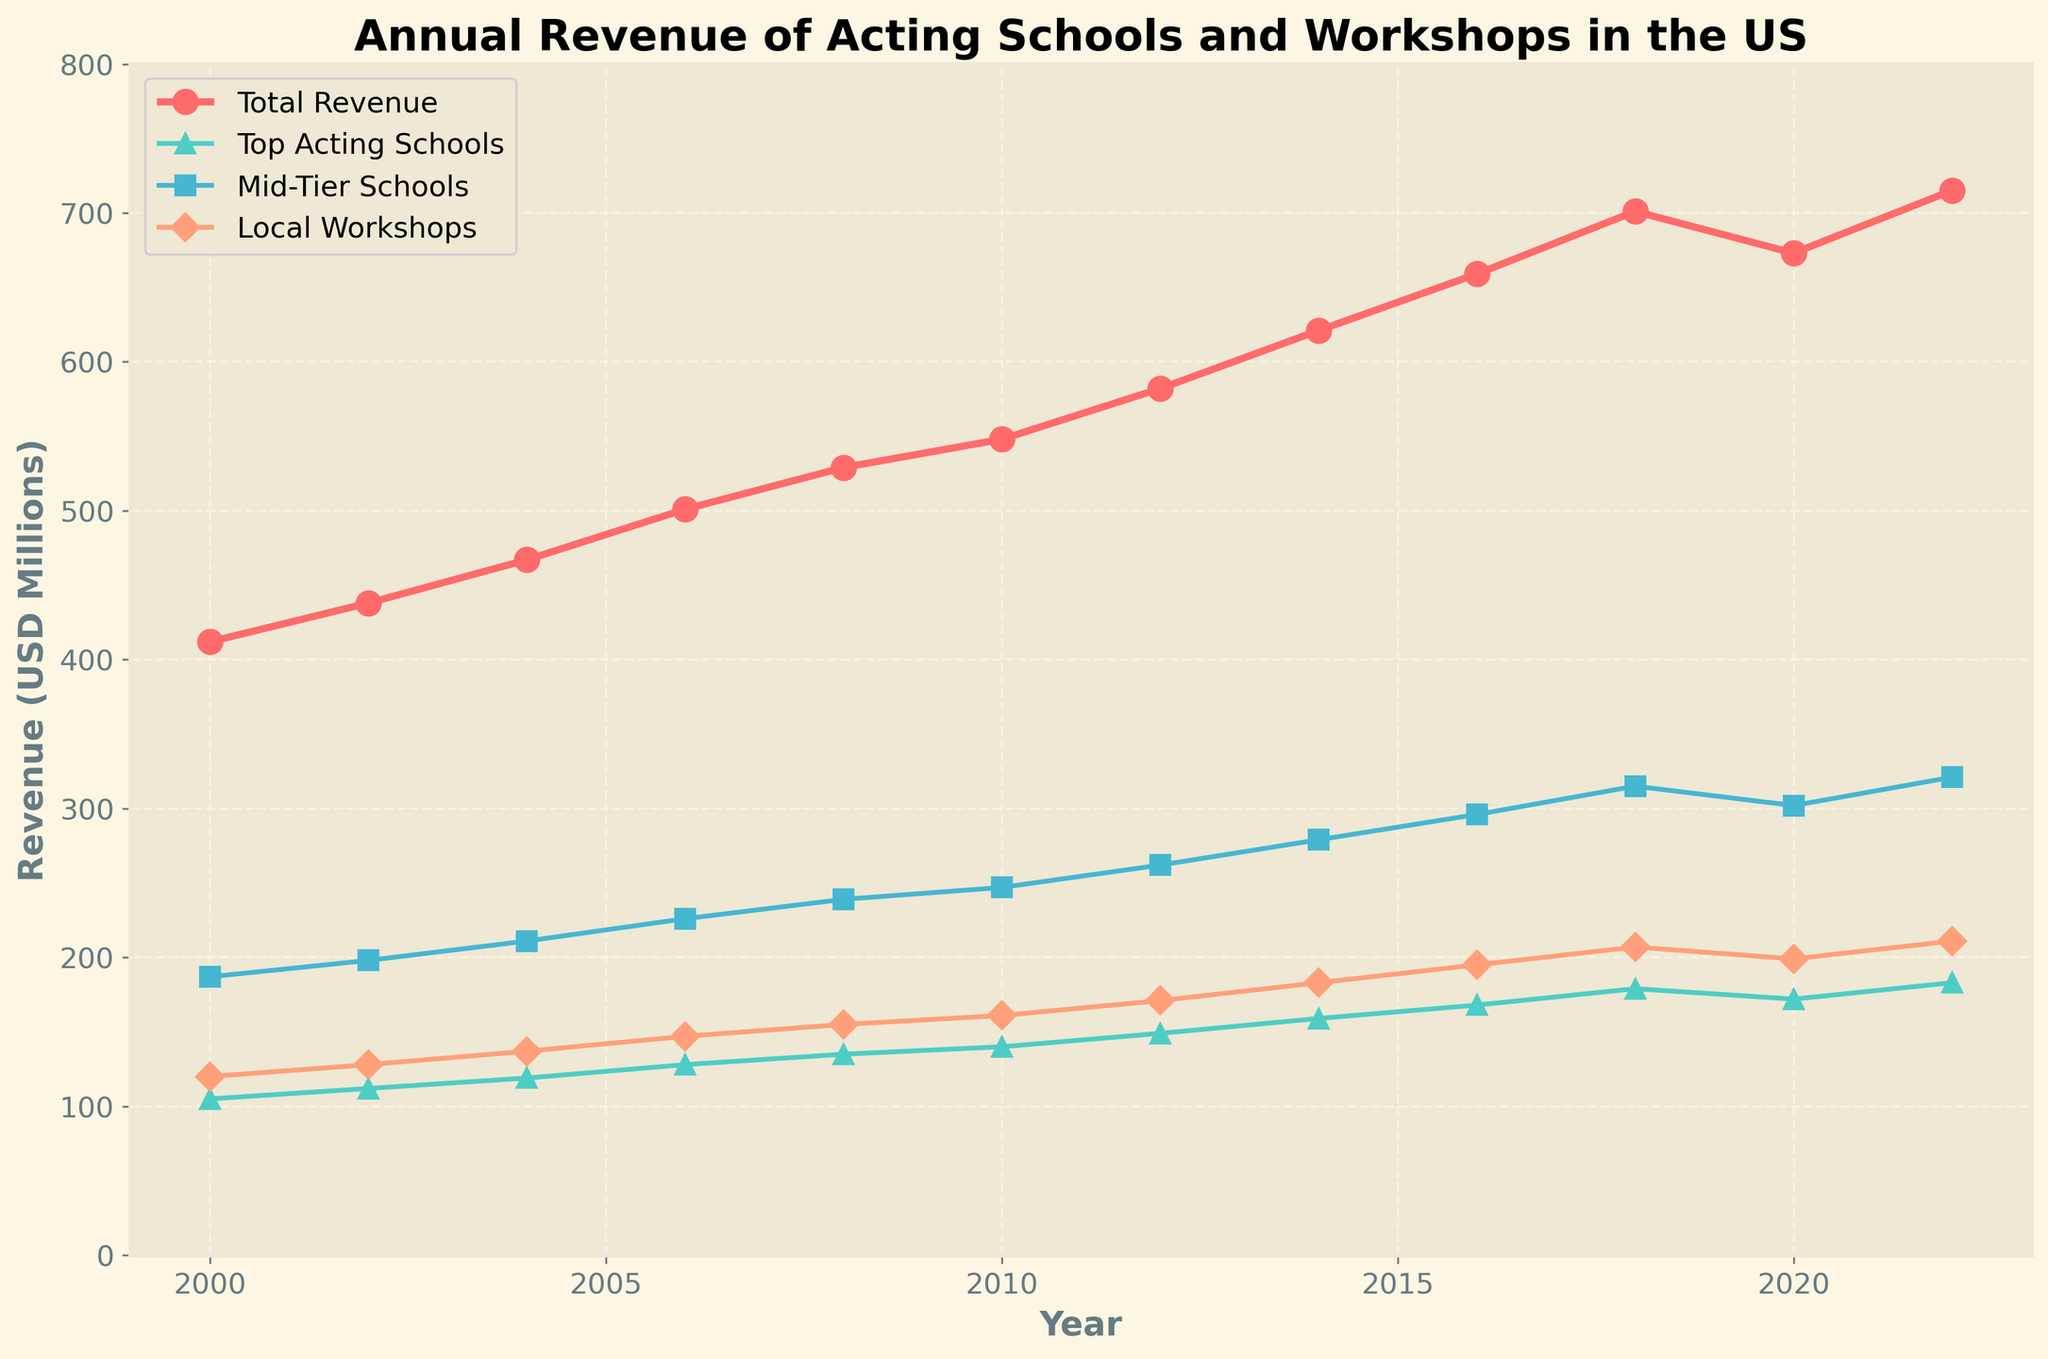What is the total annual revenue in 2018? Look at the line corresponding to Total Revenue and find the data point where the year is 2018. The value is 701 million USD.
Answer: 701 million USD What's the difference in revenue between Top Acting Schools and Local Workshops in 2022? Locate the data points for both Top Acting Schools and Local Workshops in 2022. Subtract the revenue value of Local Workshops (211 million USD) from that of Top Acting Schools (183 million USD). 183 - 211 = -28. Thus, the difference is -28 million USD.
Answer: -28 million USD Which year shows a decline in the total annual revenue compared to the previous year? Observe the Total Revenue line for any drop from one year to the next. Notice between 2018 (701 million USD) and 2020 (673 million USD).
Answer: 2020 In which year did Mid-Tier Schools first surpass 300 million USD in revenue? Check the Mid-Tier Schools line for the first instance it crosses 300 million USD. It occurred in 2018.
Answer: 2018 What is the combined revenue of Mid-Tier Schools and Local Workshops in 2016? Find the revenue values for Mid-Tier Schools and Local Workshops in 2016, then add them together. Mid-Tier Schools revenue is 296 million USD and Local Workshops revenue is 195 million USD. 296 + 195 = 491.
Answer: 491 million USD By how much did the total annual revenue increase from 2004 to 2014? Locate the Total Revenue values for 2004 (467 million USD) and 2014 (621 million USD). Subtract the 2004 value from the 2014 value. 621 - 467 = 154.
Answer: 154 million USD Which category showed the least growth between 2000 and 2022? Calculate the difference between the revenue values for each category (Top Acting Schools, Mid-Tier Schools, Local Workshops) from 2000 to 2022. The changes are: Top Acting Schools: 183 - 105 = 78 million USD, Mid-Tier Schools: 321 - 187 = 134 million USD, Local Workshops: 211 - 120 = 91 million USD. The least growth is in Top Acting Schools with 78 million USD.
Answer: Top Acting Schools Which category had a visual marker of a green downward-pointing triangle? Identify lines and markers' descriptions by their colors and shapes. The green line with downward-pointing triangles represents Top Acting Schools.
Answer: Top Acting Schools 